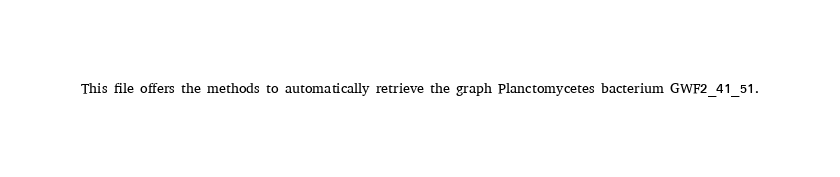Convert code to text. <code><loc_0><loc_0><loc_500><loc_500><_Python_>This file offers the methods to automatically retrieve the graph Planctomycetes bacterium GWF2_41_51.
</code> 